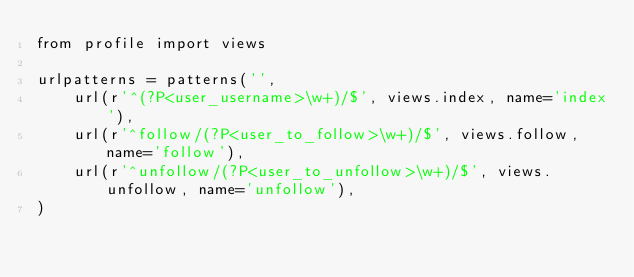<code> <loc_0><loc_0><loc_500><loc_500><_Python_>from profile import views

urlpatterns = patterns('',
    url(r'^(?P<user_username>\w+)/$', views.index, name='index'),
    url(r'^follow/(?P<user_to_follow>\w+)/$', views.follow, name='follow'),
    url(r'^unfollow/(?P<user_to_unfollow>\w+)/$', views.unfollow, name='unfollow'),
)</code> 